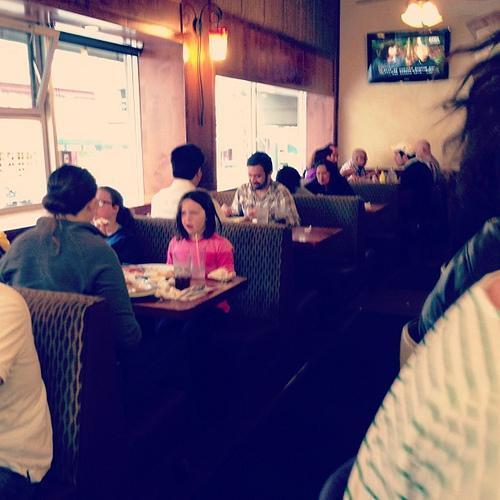How many people are wearing pink shirt?
Give a very brief answer. 1. 